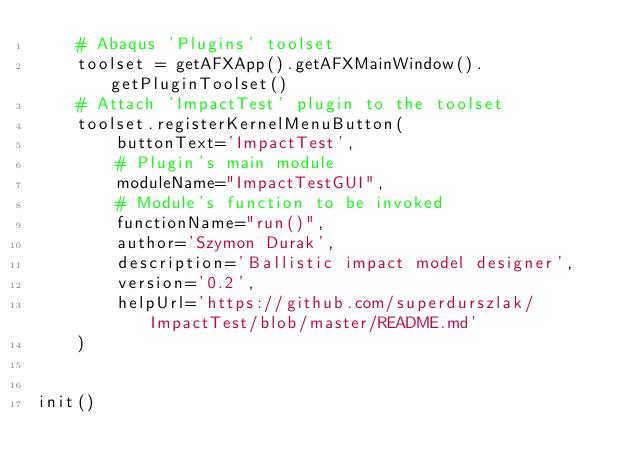<code> <loc_0><loc_0><loc_500><loc_500><_Python_>    # Abaqus 'Plugins' toolset
    toolset = getAFXApp().getAFXMainWindow().getPluginToolset()
    # Attach 'ImpactTest' plugin to the toolset
    toolset.registerKernelMenuButton(
        buttonText='ImpactTest',
        # Plugin's main module
        moduleName="ImpactTestGUI",
        # Module's function to be invoked
        functionName="run()",
        author='Szymon Durak',
        description='Ballistic impact model designer',
        version='0.2',
        helpUrl='https://github.com/superdurszlak/ImpactTest/blob/master/README.md'
    )


init()
</code> 